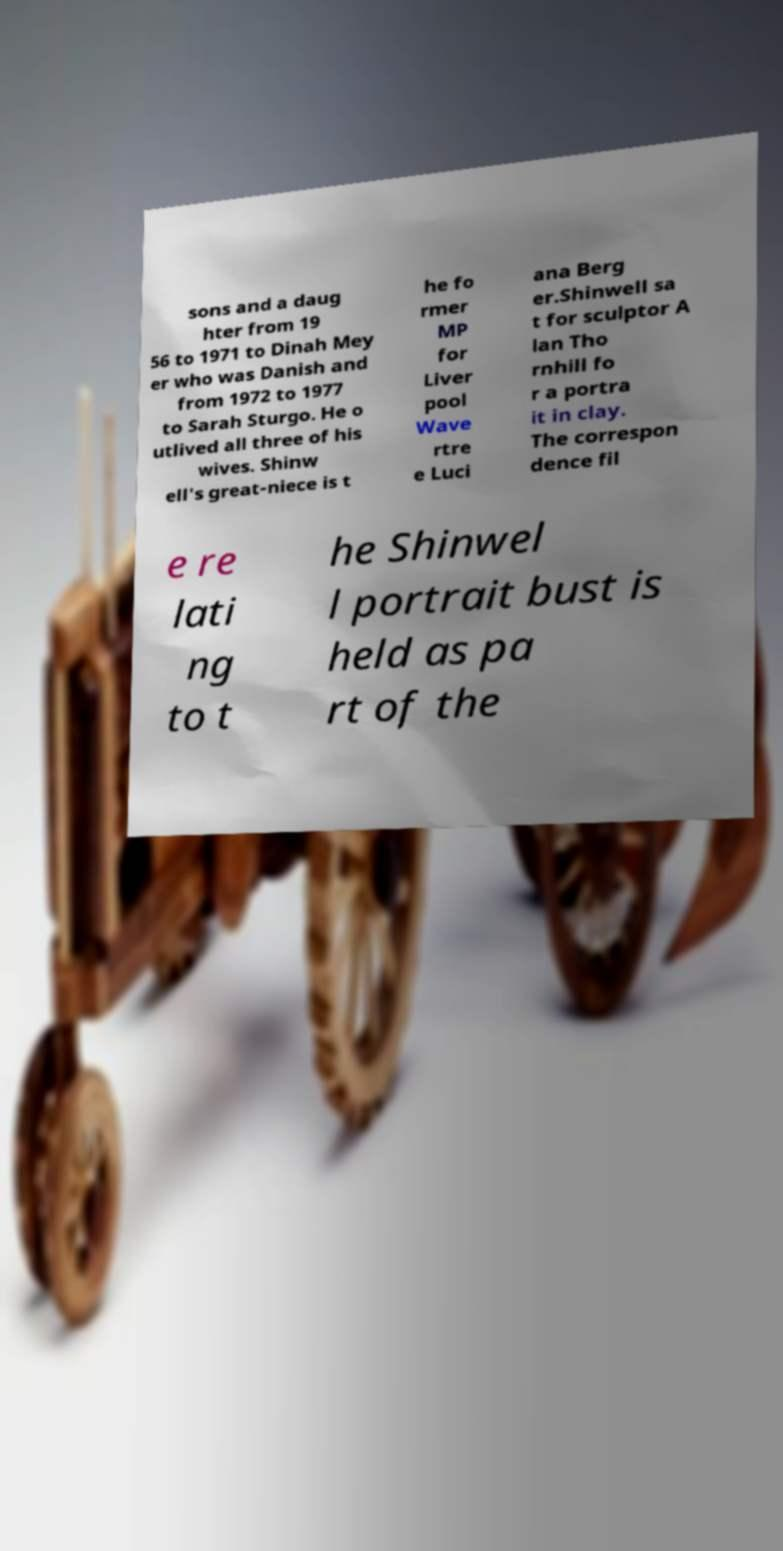Can you read and provide the text displayed in the image?This photo seems to have some interesting text. Can you extract and type it out for me? sons and a daug hter from 19 56 to 1971 to Dinah Mey er who was Danish and from 1972 to 1977 to Sarah Sturgo. He o utlived all three of his wives. Shinw ell's great-niece is t he fo rmer MP for Liver pool Wave rtre e Luci ana Berg er.Shinwell sa t for sculptor A lan Tho rnhill fo r a portra it in clay. The correspon dence fil e re lati ng to t he Shinwel l portrait bust is held as pa rt of the 